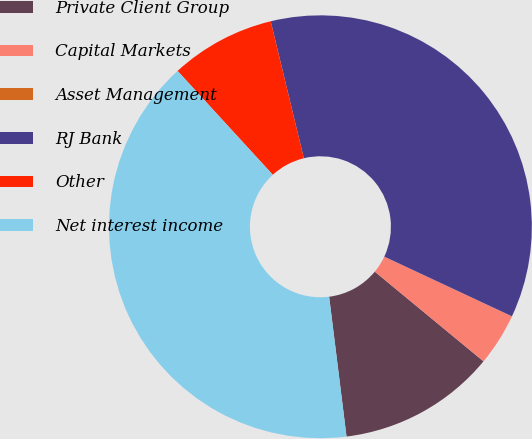<chart> <loc_0><loc_0><loc_500><loc_500><pie_chart><fcel>Private Client Group<fcel>Capital Markets<fcel>Asset Management<fcel>RJ Bank<fcel>Other<fcel>Net interest income<nl><fcel>12.05%<fcel>4.02%<fcel>0.0%<fcel>35.74%<fcel>8.03%<fcel>40.16%<nl></chart> 